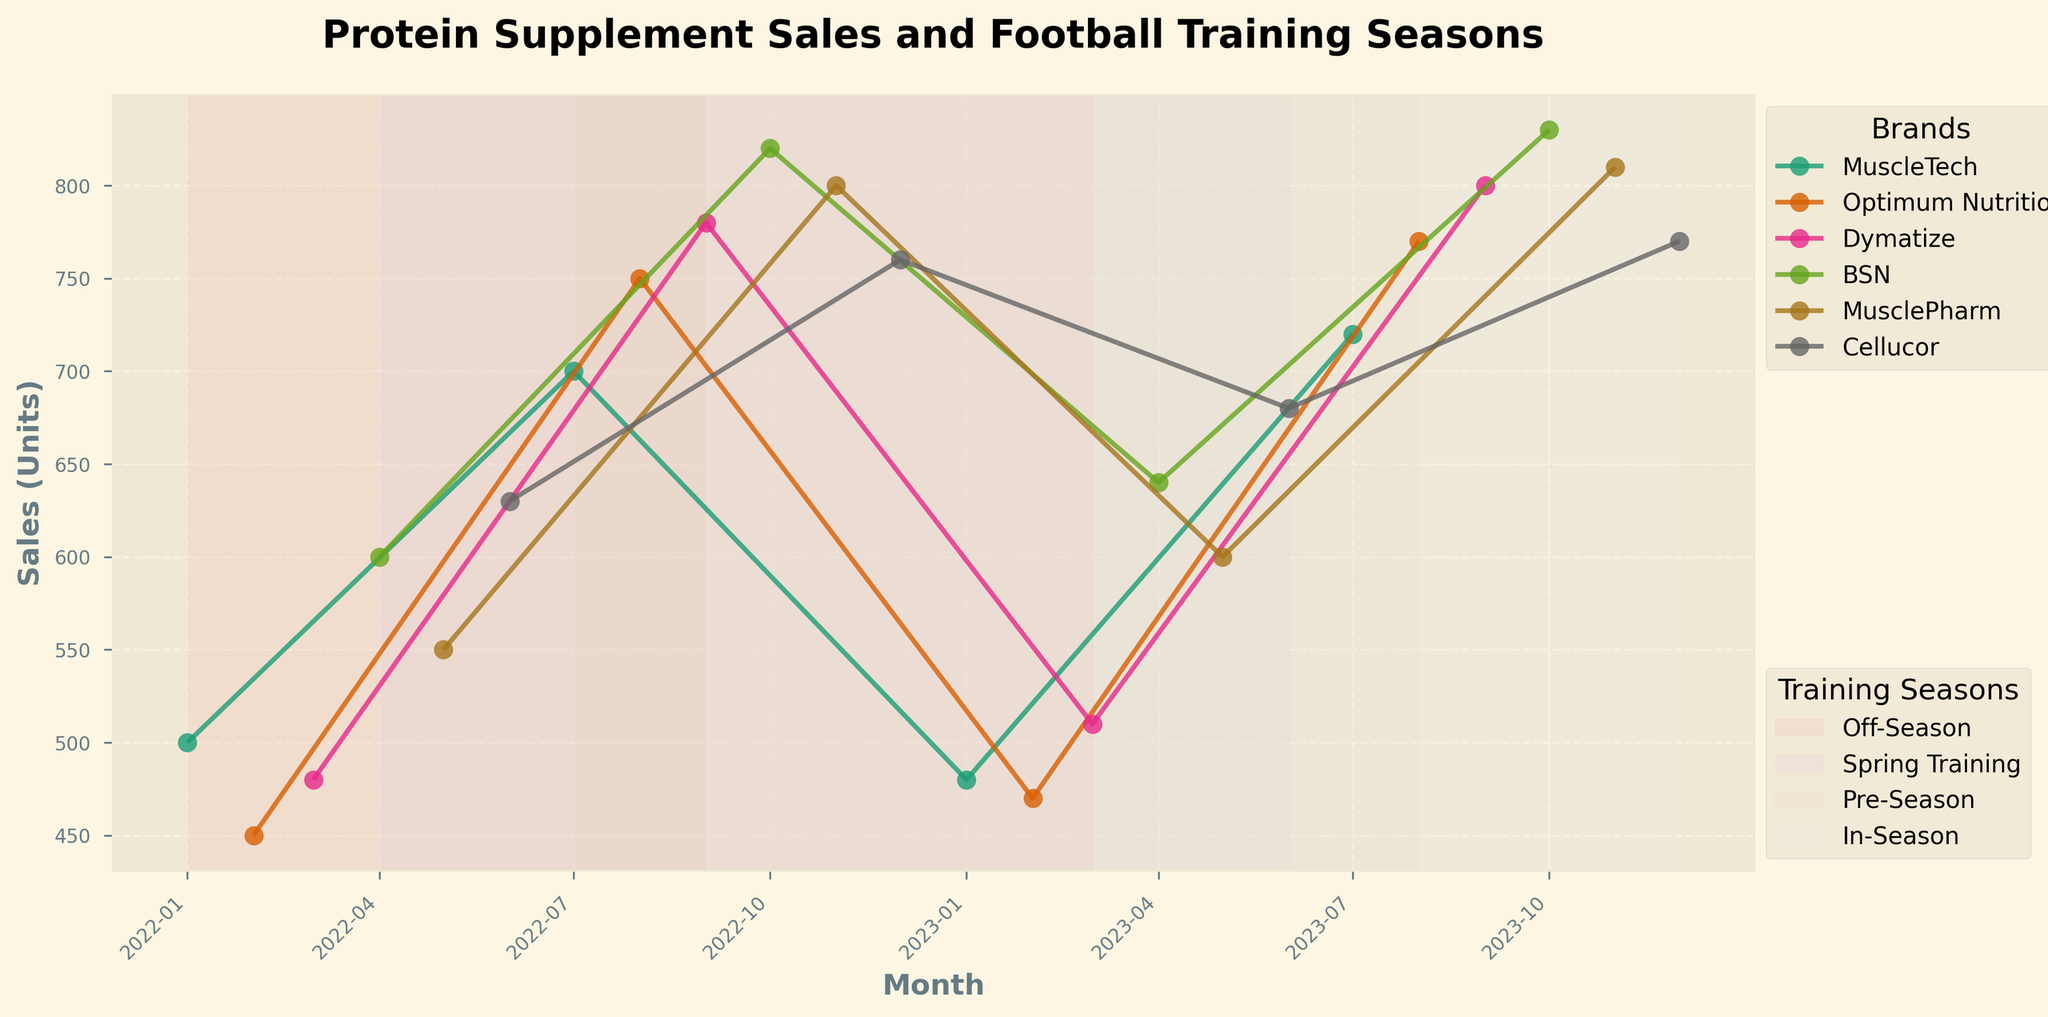Which training season shows the highest sales for MuscleTech? To answer this, observe the sales data for MuscleTech across all the highlighted training seasons. The highest sales occur during the Pre-Season when sales reach 720 units.
Answer: Pre-Season What is the title of the plot? The title of the plot can be found at the top of the graph. It reads, "Protein Supplement Sales and Football Training Seasons"
Answer: Protein Supplement Sales and Football Training Seasons How many different protein supplement brands are represented in the plot? Count the unique brands represented in the legend. There are six brands: MuscleTech, Optimum Nutrition, Dymatize, BSN, MusclePharm, and Cellucor.
Answer: Six Which month shows the highest sales for BSN? Locate the data points for BSN and identify the peak sales month. BSN's highest sales occur in October 2023 with 830 units.
Answer: October 2023 Compare the average sales of Optimum Nutrition between Off-Season and Pre-Season. Calculate the average sales for Off-Season (450 in February and 470 in February) and for Pre-Season (750 in August and 770 in August). The averages are calculated as follows: Off-Season (450+470)/2 = 460, Pre-Season (750+770)/2 = 760.
Answer: Off-Season: 460, Pre-Season: 760 Which brand shows a significant increase in sales from Off-Season to In-Season? Observe the sales trends for each brand between the Off-Season and In-Season. MusclePharm shows significant sales increase from 550 units in March to 810 units in November.
Answer: MusclePharm How does the sales trend for Cellucor change during the Spring Training season? Examine the data points for Cellucor during Spring Training. Sales increase steadily from 630 units in June 2022 to 680 units in June 2023.
Answer: Increases What pattern do you observe in protein supplement sales during the In-Season months? Review the sales trends across all brands during In-Season months (September to December). Generally, there is an upward trend in sales with several brands showing their peak sales.
Answer: Upward trend Which football training season consistently shows a rise in protein supplement sales? Compare the sales data trends across the different training seasons. The In-Season months consistently depict high sales figures across multiple brands.
Answer: In-Season What is the color coding used to highlight different football training seasons in the plot? Check the shaded regions in the plot that represent different football training seasons, typically using distinct pastel colors per season for differentiation. The exact colors may vary, but each season is uniquely colored.
Answer: Different pastel colors 